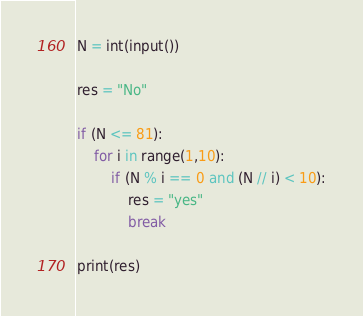Convert code to text. <code><loc_0><loc_0><loc_500><loc_500><_Python_>N = int(input())

res = "No"

if (N <= 81):
    for i in range(1,10):
        if (N % i == 0 and (N // i) < 10):
            res = "yes"
            break

print(res)</code> 